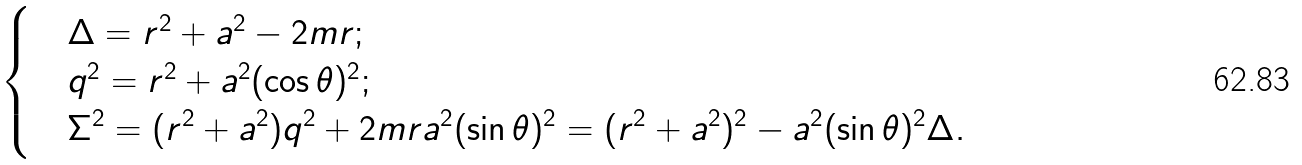<formula> <loc_0><loc_0><loc_500><loc_500>\begin{cases} & \Delta = r ^ { 2 } + a ^ { 2 } - 2 m r ; \\ & q ^ { 2 } = r ^ { 2 } + a ^ { 2 } ( \cos \theta ) ^ { 2 } ; \\ & \Sigma ^ { 2 } = ( r ^ { 2 } + a ^ { 2 } ) q ^ { 2 } + 2 m r a ^ { 2 } ( \sin \theta ) ^ { 2 } = ( r ^ { 2 } + a ^ { 2 } ) ^ { 2 } - a ^ { 2 } ( \sin \theta ) ^ { 2 } \Delta . \end{cases}</formula> 